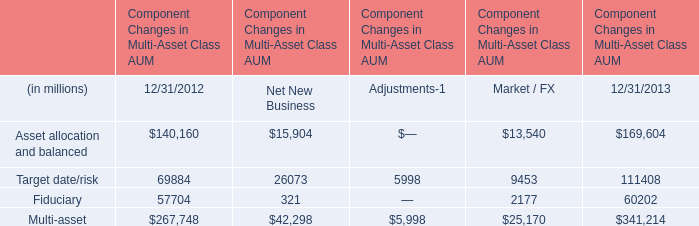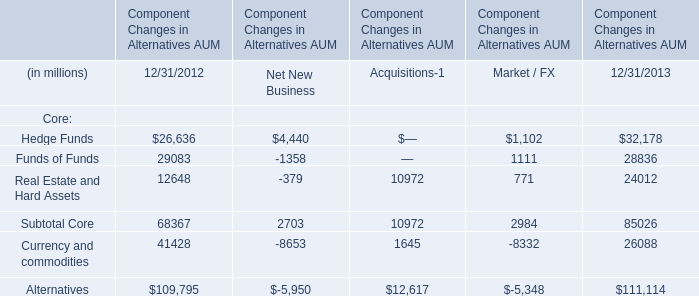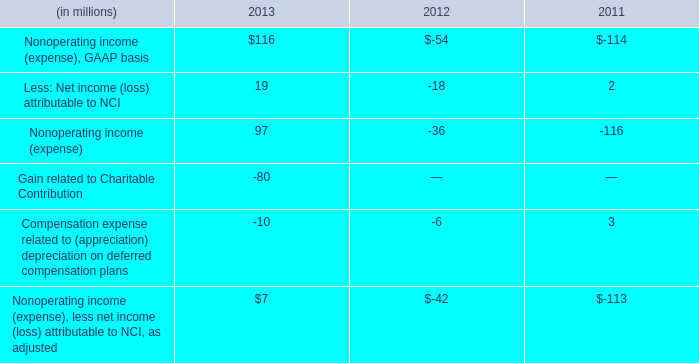What is the sum of Fiduciary in 2012 and Subtotal Core in 2013? (in million) 
Computations: (57704 + 85026)
Answer: 142730.0. 